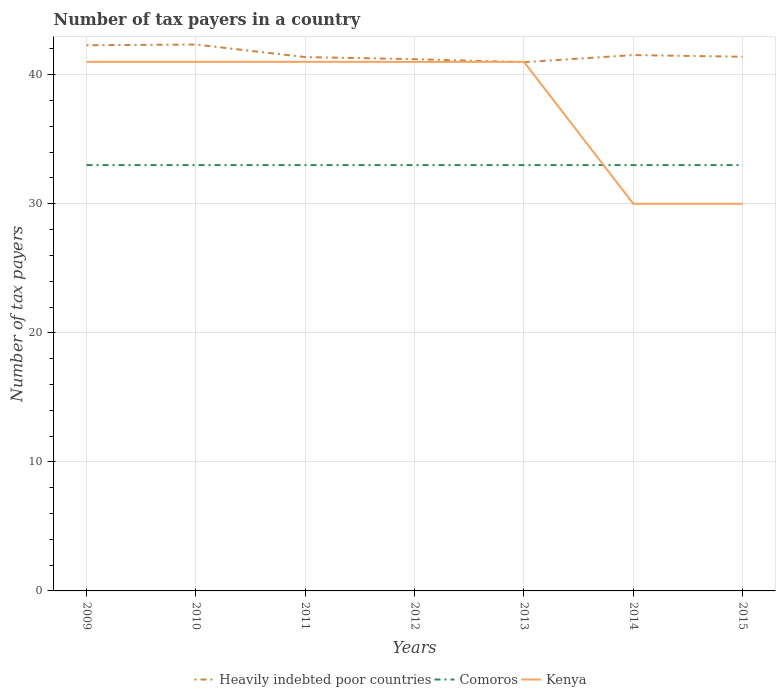Is the number of lines equal to the number of legend labels?
Ensure brevity in your answer.  Yes. Across all years, what is the maximum number of tax payers in in Heavily indebted poor countries?
Provide a succinct answer. 40.97. What is the total number of tax payers in in Comoros in the graph?
Keep it short and to the point. 0. What is the difference between the highest and the second highest number of tax payers in in Heavily indebted poor countries?
Your answer should be compact. 1.37. How many lines are there?
Offer a terse response. 3. Are the values on the major ticks of Y-axis written in scientific E-notation?
Keep it short and to the point. No. Does the graph contain any zero values?
Your answer should be very brief. No. Does the graph contain grids?
Provide a succinct answer. Yes. Where does the legend appear in the graph?
Offer a very short reply. Bottom center. What is the title of the graph?
Ensure brevity in your answer.  Number of tax payers in a country. What is the label or title of the Y-axis?
Ensure brevity in your answer.  Number of tax payers. What is the Number of tax payers of Heavily indebted poor countries in 2009?
Ensure brevity in your answer.  42.29. What is the Number of tax payers of Comoros in 2009?
Provide a succinct answer. 33. What is the Number of tax payers in Kenya in 2009?
Provide a short and direct response. 41. What is the Number of tax payers in Heavily indebted poor countries in 2010?
Give a very brief answer. 42.34. What is the Number of tax payers of Comoros in 2010?
Keep it short and to the point. 33. What is the Number of tax payers of Heavily indebted poor countries in 2011?
Offer a very short reply. 41.37. What is the Number of tax payers in Heavily indebted poor countries in 2012?
Keep it short and to the point. 41.21. What is the Number of tax payers in Kenya in 2012?
Provide a succinct answer. 41. What is the Number of tax payers of Heavily indebted poor countries in 2013?
Ensure brevity in your answer.  40.97. What is the Number of tax payers in Comoros in 2013?
Offer a terse response. 33. What is the Number of tax payers in Kenya in 2013?
Provide a succinct answer. 41. What is the Number of tax payers of Heavily indebted poor countries in 2014?
Offer a terse response. 41.53. What is the Number of tax payers of Comoros in 2014?
Offer a terse response. 33. What is the Number of tax payers of Kenya in 2014?
Your response must be concise. 30. What is the Number of tax payers of Heavily indebted poor countries in 2015?
Your answer should be very brief. 41.39. Across all years, what is the maximum Number of tax payers of Heavily indebted poor countries?
Ensure brevity in your answer.  42.34. Across all years, what is the minimum Number of tax payers of Heavily indebted poor countries?
Your response must be concise. 40.97. Across all years, what is the minimum Number of tax payers of Kenya?
Your answer should be compact. 30. What is the total Number of tax payers in Heavily indebted poor countries in the graph?
Your answer should be very brief. 291.11. What is the total Number of tax payers of Comoros in the graph?
Keep it short and to the point. 231. What is the total Number of tax payers in Kenya in the graph?
Provide a succinct answer. 265. What is the difference between the Number of tax payers in Heavily indebted poor countries in 2009 and that in 2010?
Offer a terse response. -0.05. What is the difference between the Number of tax payers in Comoros in 2009 and that in 2010?
Make the answer very short. 0. What is the difference between the Number of tax payers of Kenya in 2009 and that in 2010?
Give a very brief answer. 0. What is the difference between the Number of tax payers in Heavily indebted poor countries in 2009 and that in 2011?
Your response must be concise. 0.92. What is the difference between the Number of tax payers of Comoros in 2009 and that in 2011?
Keep it short and to the point. 0. What is the difference between the Number of tax payers in Kenya in 2009 and that in 2011?
Provide a succinct answer. 0. What is the difference between the Number of tax payers of Heavily indebted poor countries in 2009 and that in 2012?
Ensure brevity in your answer.  1.08. What is the difference between the Number of tax payers of Comoros in 2009 and that in 2012?
Offer a very short reply. 0. What is the difference between the Number of tax payers of Heavily indebted poor countries in 2009 and that in 2013?
Give a very brief answer. 1.32. What is the difference between the Number of tax payers of Comoros in 2009 and that in 2013?
Your answer should be compact. 0. What is the difference between the Number of tax payers in Heavily indebted poor countries in 2009 and that in 2014?
Make the answer very short. 0.76. What is the difference between the Number of tax payers of Comoros in 2009 and that in 2014?
Offer a terse response. 0. What is the difference between the Number of tax payers of Heavily indebted poor countries in 2009 and that in 2015?
Keep it short and to the point. 0.89. What is the difference between the Number of tax payers in Comoros in 2009 and that in 2015?
Provide a short and direct response. 0. What is the difference between the Number of tax payers in Heavily indebted poor countries in 2010 and that in 2011?
Give a very brief answer. 0.97. What is the difference between the Number of tax payers in Heavily indebted poor countries in 2010 and that in 2012?
Your answer should be compact. 1.13. What is the difference between the Number of tax payers of Comoros in 2010 and that in 2012?
Ensure brevity in your answer.  0. What is the difference between the Number of tax payers of Kenya in 2010 and that in 2012?
Offer a terse response. 0. What is the difference between the Number of tax payers in Heavily indebted poor countries in 2010 and that in 2013?
Offer a terse response. 1.37. What is the difference between the Number of tax payers of Comoros in 2010 and that in 2013?
Your answer should be compact. 0. What is the difference between the Number of tax payers in Kenya in 2010 and that in 2013?
Ensure brevity in your answer.  0. What is the difference between the Number of tax payers of Heavily indebted poor countries in 2010 and that in 2014?
Make the answer very short. 0.82. What is the difference between the Number of tax payers in Comoros in 2010 and that in 2014?
Make the answer very short. 0. What is the difference between the Number of tax payers in Heavily indebted poor countries in 2010 and that in 2015?
Ensure brevity in your answer.  0.95. What is the difference between the Number of tax payers in Kenya in 2010 and that in 2015?
Provide a succinct answer. 11. What is the difference between the Number of tax payers in Heavily indebted poor countries in 2011 and that in 2012?
Your answer should be compact. 0.16. What is the difference between the Number of tax payers of Kenya in 2011 and that in 2012?
Provide a succinct answer. 0. What is the difference between the Number of tax payers of Heavily indebted poor countries in 2011 and that in 2013?
Keep it short and to the point. 0.39. What is the difference between the Number of tax payers of Comoros in 2011 and that in 2013?
Keep it short and to the point. 0. What is the difference between the Number of tax payers of Heavily indebted poor countries in 2011 and that in 2014?
Your response must be concise. -0.16. What is the difference between the Number of tax payers in Kenya in 2011 and that in 2014?
Provide a succinct answer. 11. What is the difference between the Number of tax payers in Heavily indebted poor countries in 2011 and that in 2015?
Ensure brevity in your answer.  -0.03. What is the difference between the Number of tax payers of Comoros in 2011 and that in 2015?
Keep it short and to the point. 0. What is the difference between the Number of tax payers of Kenya in 2011 and that in 2015?
Offer a very short reply. 11. What is the difference between the Number of tax payers of Heavily indebted poor countries in 2012 and that in 2013?
Your answer should be very brief. 0.24. What is the difference between the Number of tax payers in Heavily indebted poor countries in 2012 and that in 2014?
Provide a short and direct response. -0.32. What is the difference between the Number of tax payers of Heavily indebted poor countries in 2012 and that in 2015?
Keep it short and to the point. -0.18. What is the difference between the Number of tax payers in Kenya in 2012 and that in 2015?
Your answer should be compact. 11. What is the difference between the Number of tax payers in Heavily indebted poor countries in 2013 and that in 2014?
Offer a very short reply. -0.55. What is the difference between the Number of tax payers of Comoros in 2013 and that in 2014?
Make the answer very short. 0. What is the difference between the Number of tax payers in Kenya in 2013 and that in 2014?
Provide a short and direct response. 11. What is the difference between the Number of tax payers of Heavily indebted poor countries in 2013 and that in 2015?
Offer a terse response. -0.42. What is the difference between the Number of tax payers of Comoros in 2013 and that in 2015?
Ensure brevity in your answer.  0. What is the difference between the Number of tax payers in Kenya in 2013 and that in 2015?
Offer a terse response. 11. What is the difference between the Number of tax payers in Heavily indebted poor countries in 2014 and that in 2015?
Keep it short and to the point. 0.13. What is the difference between the Number of tax payers of Comoros in 2014 and that in 2015?
Your answer should be compact. 0. What is the difference between the Number of tax payers in Heavily indebted poor countries in 2009 and the Number of tax payers in Comoros in 2010?
Your response must be concise. 9.29. What is the difference between the Number of tax payers of Heavily indebted poor countries in 2009 and the Number of tax payers of Kenya in 2010?
Ensure brevity in your answer.  1.29. What is the difference between the Number of tax payers in Heavily indebted poor countries in 2009 and the Number of tax payers in Comoros in 2011?
Offer a very short reply. 9.29. What is the difference between the Number of tax payers in Heavily indebted poor countries in 2009 and the Number of tax payers in Kenya in 2011?
Your response must be concise. 1.29. What is the difference between the Number of tax payers in Heavily indebted poor countries in 2009 and the Number of tax payers in Comoros in 2012?
Ensure brevity in your answer.  9.29. What is the difference between the Number of tax payers in Heavily indebted poor countries in 2009 and the Number of tax payers in Kenya in 2012?
Keep it short and to the point. 1.29. What is the difference between the Number of tax payers of Heavily indebted poor countries in 2009 and the Number of tax payers of Comoros in 2013?
Make the answer very short. 9.29. What is the difference between the Number of tax payers of Heavily indebted poor countries in 2009 and the Number of tax payers of Kenya in 2013?
Your response must be concise. 1.29. What is the difference between the Number of tax payers of Heavily indebted poor countries in 2009 and the Number of tax payers of Comoros in 2014?
Keep it short and to the point. 9.29. What is the difference between the Number of tax payers in Heavily indebted poor countries in 2009 and the Number of tax payers in Kenya in 2014?
Ensure brevity in your answer.  12.29. What is the difference between the Number of tax payers of Heavily indebted poor countries in 2009 and the Number of tax payers of Comoros in 2015?
Your answer should be compact. 9.29. What is the difference between the Number of tax payers in Heavily indebted poor countries in 2009 and the Number of tax payers in Kenya in 2015?
Provide a short and direct response. 12.29. What is the difference between the Number of tax payers of Comoros in 2009 and the Number of tax payers of Kenya in 2015?
Provide a succinct answer. 3. What is the difference between the Number of tax payers of Heavily indebted poor countries in 2010 and the Number of tax payers of Comoros in 2011?
Your answer should be compact. 9.34. What is the difference between the Number of tax payers in Heavily indebted poor countries in 2010 and the Number of tax payers in Kenya in 2011?
Offer a terse response. 1.34. What is the difference between the Number of tax payers in Heavily indebted poor countries in 2010 and the Number of tax payers in Comoros in 2012?
Make the answer very short. 9.34. What is the difference between the Number of tax payers of Heavily indebted poor countries in 2010 and the Number of tax payers of Kenya in 2012?
Keep it short and to the point. 1.34. What is the difference between the Number of tax payers of Comoros in 2010 and the Number of tax payers of Kenya in 2012?
Give a very brief answer. -8. What is the difference between the Number of tax payers in Heavily indebted poor countries in 2010 and the Number of tax payers in Comoros in 2013?
Make the answer very short. 9.34. What is the difference between the Number of tax payers of Heavily indebted poor countries in 2010 and the Number of tax payers of Kenya in 2013?
Your response must be concise. 1.34. What is the difference between the Number of tax payers of Comoros in 2010 and the Number of tax payers of Kenya in 2013?
Offer a very short reply. -8. What is the difference between the Number of tax payers of Heavily indebted poor countries in 2010 and the Number of tax payers of Comoros in 2014?
Your answer should be compact. 9.34. What is the difference between the Number of tax payers of Heavily indebted poor countries in 2010 and the Number of tax payers of Kenya in 2014?
Your answer should be compact. 12.34. What is the difference between the Number of tax payers of Heavily indebted poor countries in 2010 and the Number of tax payers of Comoros in 2015?
Offer a very short reply. 9.34. What is the difference between the Number of tax payers of Heavily indebted poor countries in 2010 and the Number of tax payers of Kenya in 2015?
Offer a terse response. 12.34. What is the difference between the Number of tax payers in Heavily indebted poor countries in 2011 and the Number of tax payers in Comoros in 2012?
Provide a short and direct response. 8.37. What is the difference between the Number of tax payers of Heavily indebted poor countries in 2011 and the Number of tax payers of Kenya in 2012?
Ensure brevity in your answer.  0.37. What is the difference between the Number of tax payers in Heavily indebted poor countries in 2011 and the Number of tax payers in Comoros in 2013?
Offer a terse response. 8.37. What is the difference between the Number of tax payers of Heavily indebted poor countries in 2011 and the Number of tax payers of Kenya in 2013?
Offer a terse response. 0.37. What is the difference between the Number of tax payers of Comoros in 2011 and the Number of tax payers of Kenya in 2013?
Ensure brevity in your answer.  -8. What is the difference between the Number of tax payers in Heavily indebted poor countries in 2011 and the Number of tax payers in Comoros in 2014?
Make the answer very short. 8.37. What is the difference between the Number of tax payers in Heavily indebted poor countries in 2011 and the Number of tax payers in Kenya in 2014?
Your answer should be compact. 11.37. What is the difference between the Number of tax payers in Heavily indebted poor countries in 2011 and the Number of tax payers in Comoros in 2015?
Offer a very short reply. 8.37. What is the difference between the Number of tax payers of Heavily indebted poor countries in 2011 and the Number of tax payers of Kenya in 2015?
Your answer should be very brief. 11.37. What is the difference between the Number of tax payers in Heavily indebted poor countries in 2012 and the Number of tax payers in Comoros in 2013?
Provide a short and direct response. 8.21. What is the difference between the Number of tax payers of Heavily indebted poor countries in 2012 and the Number of tax payers of Kenya in 2013?
Give a very brief answer. 0.21. What is the difference between the Number of tax payers of Heavily indebted poor countries in 2012 and the Number of tax payers of Comoros in 2014?
Make the answer very short. 8.21. What is the difference between the Number of tax payers in Heavily indebted poor countries in 2012 and the Number of tax payers in Kenya in 2014?
Your answer should be compact. 11.21. What is the difference between the Number of tax payers of Comoros in 2012 and the Number of tax payers of Kenya in 2014?
Your answer should be very brief. 3. What is the difference between the Number of tax payers in Heavily indebted poor countries in 2012 and the Number of tax payers in Comoros in 2015?
Make the answer very short. 8.21. What is the difference between the Number of tax payers of Heavily indebted poor countries in 2012 and the Number of tax payers of Kenya in 2015?
Offer a very short reply. 11.21. What is the difference between the Number of tax payers of Comoros in 2012 and the Number of tax payers of Kenya in 2015?
Your answer should be compact. 3. What is the difference between the Number of tax payers in Heavily indebted poor countries in 2013 and the Number of tax payers in Comoros in 2014?
Offer a very short reply. 7.97. What is the difference between the Number of tax payers in Heavily indebted poor countries in 2013 and the Number of tax payers in Kenya in 2014?
Make the answer very short. 10.97. What is the difference between the Number of tax payers in Heavily indebted poor countries in 2013 and the Number of tax payers in Comoros in 2015?
Ensure brevity in your answer.  7.97. What is the difference between the Number of tax payers in Heavily indebted poor countries in 2013 and the Number of tax payers in Kenya in 2015?
Provide a succinct answer. 10.97. What is the difference between the Number of tax payers in Comoros in 2013 and the Number of tax payers in Kenya in 2015?
Your answer should be very brief. 3. What is the difference between the Number of tax payers of Heavily indebted poor countries in 2014 and the Number of tax payers of Comoros in 2015?
Give a very brief answer. 8.53. What is the difference between the Number of tax payers in Heavily indebted poor countries in 2014 and the Number of tax payers in Kenya in 2015?
Ensure brevity in your answer.  11.53. What is the difference between the Number of tax payers of Comoros in 2014 and the Number of tax payers of Kenya in 2015?
Give a very brief answer. 3. What is the average Number of tax payers in Heavily indebted poor countries per year?
Give a very brief answer. 41.59. What is the average Number of tax payers in Kenya per year?
Your answer should be very brief. 37.86. In the year 2009, what is the difference between the Number of tax payers in Heavily indebted poor countries and Number of tax payers in Comoros?
Offer a terse response. 9.29. In the year 2009, what is the difference between the Number of tax payers of Heavily indebted poor countries and Number of tax payers of Kenya?
Provide a succinct answer. 1.29. In the year 2009, what is the difference between the Number of tax payers of Comoros and Number of tax payers of Kenya?
Provide a short and direct response. -8. In the year 2010, what is the difference between the Number of tax payers in Heavily indebted poor countries and Number of tax payers in Comoros?
Provide a short and direct response. 9.34. In the year 2010, what is the difference between the Number of tax payers in Heavily indebted poor countries and Number of tax payers in Kenya?
Your response must be concise. 1.34. In the year 2011, what is the difference between the Number of tax payers of Heavily indebted poor countries and Number of tax payers of Comoros?
Ensure brevity in your answer.  8.37. In the year 2011, what is the difference between the Number of tax payers in Heavily indebted poor countries and Number of tax payers in Kenya?
Your response must be concise. 0.37. In the year 2012, what is the difference between the Number of tax payers of Heavily indebted poor countries and Number of tax payers of Comoros?
Offer a very short reply. 8.21. In the year 2012, what is the difference between the Number of tax payers of Heavily indebted poor countries and Number of tax payers of Kenya?
Offer a terse response. 0.21. In the year 2012, what is the difference between the Number of tax payers of Comoros and Number of tax payers of Kenya?
Give a very brief answer. -8. In the year 2013, what is the difference between the Number of tax payers in Heavily indebted poor countries and Number of tax payers in Comoros?
Give a very brief answer. 7.97. In the year 2013, what is the difference between the Number of tax payers in Heavily indebted poor countries and Number of tax payers in Kenya?
Keep it short and to the point. -0.03. In the year 2013, what is the difference between the Number of tax payers in Comoros and Number of tax payers in Kenya?
Make the answer very short. -8. In the year 2014, what is the difference between the Number of tax payers in Heavily indebted poor countries and Number of tax payers in Comoros?
Offer a very short reply. 8.53. In the year 2014, what is the difference between the Number of tax payers of Heavily indebted poor countries and Number of tax payers of Kenya?
Provide a succinct answer. 11.53. In the year 2015, what is the difference between the Number of tax payers of Heavily indebted poor countries and Number of tax payers of Comoros?
Your answer should be compact. 8.39. In the year 2015, what is the difference between the Number of tax payers in Heavily indebted poor countries and Number of tax payers in Kenya?
Your answer should be very brief. 11.39. What is the ratio of the Number of tax payers of Comoros in 2009 to that in 2010?
Ensure brevity in your answer.  1. What is the ratio of the Number of tax payers of Heavily indebted poor countries in 2009 to that in 2011?
Offer a very short reply. 1.02. What is the ratio of the Number of tax payers in Comoros in 2009 to that in 2011?
Offer a terse response. 1. What is the ratio of the Number of tax payers in Heavily indebted poor countries in 2009 to that in 2012?
Offer a terse response. 1.03. What is the ratio of the Number of tax payers in Comoros in 2009 to that in 2012?
Provide a short and direct response. 1. What is the ratio of the Number of tax payers of Heavily indebted poor countries in 2009 to that in 2013?
Your response must be concise. 1.03. What is the ratio of the Number of tax payers in Kenya in 2009 to that in 2013?
Give a very brief answer. 1. What is the ratio of the Number of tax payers in Heavily indebted poor countries in 2009 to that in 2014?
Offer a terse response. 1.02. What is the ratio of the Number of tax payers of Kenya in 2009 to that in 2014?
Keep it short and to the point. 1.37. What is the ratio of the Number of tax payers in Heavily indebted poor countries in 2009 to that in 2015?
Make the answer very short. 1.02. What is the ratio of the Number of tax payers of Kenya in 2009 to that in 2015?
Give a very brief answer. 1.37. What is the ratio of the Number of tax payers in Heavily indebted poor countries in 2010 to that in 2011?
Your answer should be very brief. 1.02. What is the ratio of the Number of tax payers in Kenya in 2010 to that in 2011?
Make the answer very short. 1. What is the ratio of the Number of tax payers of Heavily indebted poor countries in 2010 to that in 2012?
Offer a terse response. 1.03. What is the ratio of the Number of tax payers of Comoros in 2010 to that in 2012?
Make the answer very short. 1. What is the ratio of the Number of tax payers of Heavily indebted poor countries in 2010 to that in 2013?
Provide a short and direct response. 1.03. What is the ratio of the Number of tax payers in Comoros in 2010 to that in 2013?
Keep it short and to the point. 1. What is the ratio of the Number of tax payers of Kenya in 2010 to that in 2013?
Make the answer very short. 1. What is the ratio of the Number of tax payers in Heavily indebted poor countries in 2010 to that in 2014?
Give a very brief answer. 1.02. What is the ratio of the Number of tax payers in Comoros in 2010 to that in 2014?
Offer a terse response. 1. What is the ratio of the Number of tax payers in Kenya in 2010 to that in 2014?
Offer a very short reply. 1.37. What is the ratio of the Number of tax payers of Heavily indebted poor countries in 2010 to that in 2015?
Your answer should be compact. 1.02. What is the ratio of the Number of tax payers in Comoros in 2010 to that in 2015?
Give a very brief answer. 1. What is the ratio of the Number of tax payers of Kenya in 2010 to that in 2015?
Keep it short and to the point. 1.37. What is the ratio of the Number of tax payers of Comoros in 2011 to that in 2012?
Your response must be concise. 1. What is the ratio of the Number of tax payers of Kenya in 2011 to that in 2012?
Offer a very short reply. 1. What is the ratio of the Number of tax payers in Heavily indebted poor countries in 2011 to that in 2013?
Offer a terse response. 1.01. What is the ratio of the Number of tax payers in Comoros in 2011 to that in 2013?
Your answer should be very brief. 1. What is the ratio of the Number of tax payers of Kenya in 2011 to that in 2014?
Offer a terse response. 1.37. What is the ratio of the Number of tax payers of Comoros in 2011 to that in 2015?
Provide a short and direct response. 1. What is the ratio of the Number of tax payers of Kenya in 2011 to that in 2015?
Keep it short and to the point. 1.37. What is the ratio of the Number of tax payers of Kenya in 2012 to that in 2014?
Ensure brevity in your answer.  1.37. What is the ratio of the Number of tax payers of Comoros in 2012 to that in 2015?
Give a very brief answer. 1. What is the ratio of the Number of tax payers of Kenya in 2012 to that in 2015?
Make the answer very short. 1.37. What is the ratio of the Number of tax payers of Heavily indebted poor countries in 2013 to that in 2014?
Your answer should be compact. 0.99. What is the ratio of the Number of tax payers of Kenya in 2013 to that in 2014?
Your answer should be compact. 1.37. What is the ratio of the Number of tax payers of Heavily indebted poor countries in 2013 to that in 2015?
Make the answer very short. 0.99. What is the ratio of the Number of tax payers of Comoros in 2013 to that in 2015?
Your answer should be compact. 1. What is the ratio of the Number of tax payers in Kenya in 2013 to that in 2015?
Give a very brief answer. 1.37. What is the ratio of the Number of tax payers of Heavily indebted poor countries in 2014 to that in 2015?
Ensure brevity in your answer.  1. What is the ratio of the Number of tax payers of Comoros in 2014 to that in 2015?
Your answer should be compact. 1. What is the difference between the highest and the second highest Number of tax payers of Heavily indebted poor countries?
Offer a very short reply. 0.05. What is the difference between the highest and the second highest Number of tax payers in Comoros?
Your answer should be compact. 0. What is the difference between the highest and the second highest Number of tax payers in Kenya?
Offer a very short reply. 0. What is the difference between the highest and the lowest Number of tax payers in Heavily indebted poor countries?
Offer a very short reply. 1.37. What is the difference between the highest and the lowest Number of tax payers in Kenya?
Your answer should be very brief. 11. 